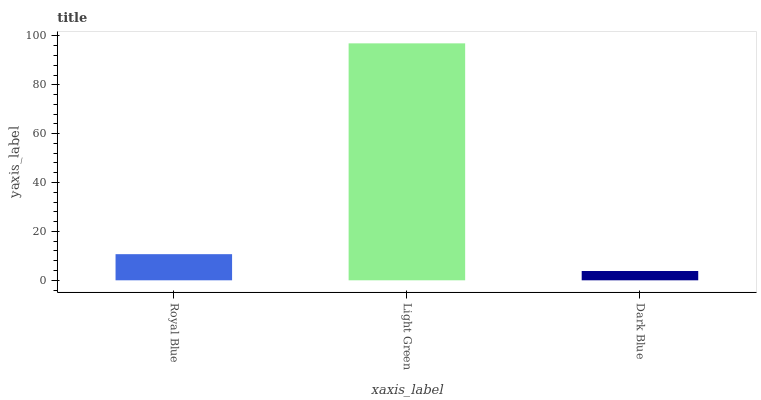Is Dark Blue the minimum?
Answer yes or no. Yes. Is Light Green the maximum?
Answer yes or no. Yes. Is Light Green the minimum?
Answer yes or no. No. Is Dark Blue the maximum?
Answer yes or no. No. Is Light Green greater than Dark Blue?
Answer yes or no. Yes. Is Dark Blue less than Light Green?
Answer yes or no. Yes. Is Dark Blue greater than Light Green?
Answer yes or no. No. Is Light Green less than Dark Blue?
Answer yes or no. No. Is Royal Blue the high median?
Answer yes or no. Yes. Is Royal Blue the low median?
Answer yes or no. Yes. Is Light Green the high median?
Answer yes or no. No. Is Dark Blue the low median?
Answer yes or no. No. 